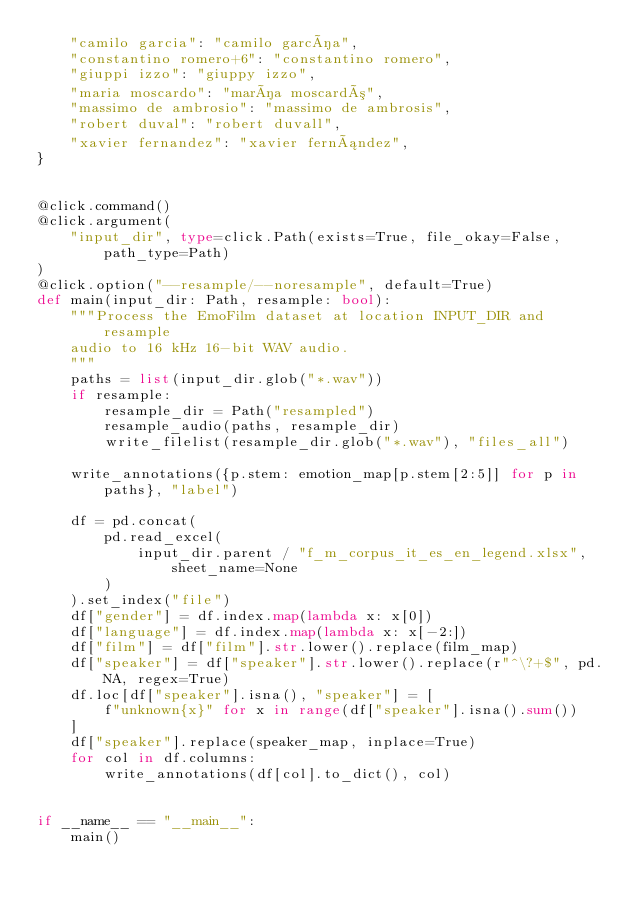Convert code to text. <code><loc_0><loc_0><loc_500><loc_500><_Python_>    "camilo garcia": "camilo garcía",
    "constantino romero+6": "constantino romero",
    "giuppi izzo": "giuppy izzo",
    "maria moscardo": "maría moscardó",
    "massimo de ambrosio": "massimo de ambrosis",
    "robert duval": "robert duvall",
    "xavier fernandez": "xavier fernández",
}


@click.command()
@click.argument(
    "input_dir", type=click.Path(exists=True, file_okay=False, path_type=Path)
)
@click.option("--resample/--noresample", default=True)
def main(input_dir: Path, resample: bool):
    """Process the EmoFilm dataset at location INPUT_DIR and resample
    audio to 16 kHz 16-bit WAV audio.
    """
    paths = list(input_dir.glob("*.wav"))
    if resample:
        resample_dir = Path("resampled")
        resample_audio(paths, resample_dir)
        write_filelist(resample_dir.glob("*.wav"), "files_all")

    write_annotations({p.stem: emotion_map[p.stem[2:5]] for p in paths}, "label")

    df = pd.concat(
        pd.read_excel(
            input_dir.parent / "f_m_corpus_it_es_en_legend.xlsx", sheet_name=None
        )
    ).set_index("file")
    df["gender"] = df.index.map(lambda x: x[0])
    df["language"] = df.index.map(lambda x: x[-2:])
    df["film"] = df["film"].str.lower().replace(film_map)
    df["speaker"] = df["speaker"].str.lower().replace(r"^\?+$", pd.NA, regex=True)
    df.loc[df["speaker"].isna(), "speaker"] = [
        f"unknown{x}" for x in range(df["speaker"].isna().sum())
    ]
    df["speaker"].replace(speaker_map, inplace=True)
    for col in df.columns:
        write_annotations(df[col].to_dict(), col)


if __name__ == "__main__":
    main()
</code> 